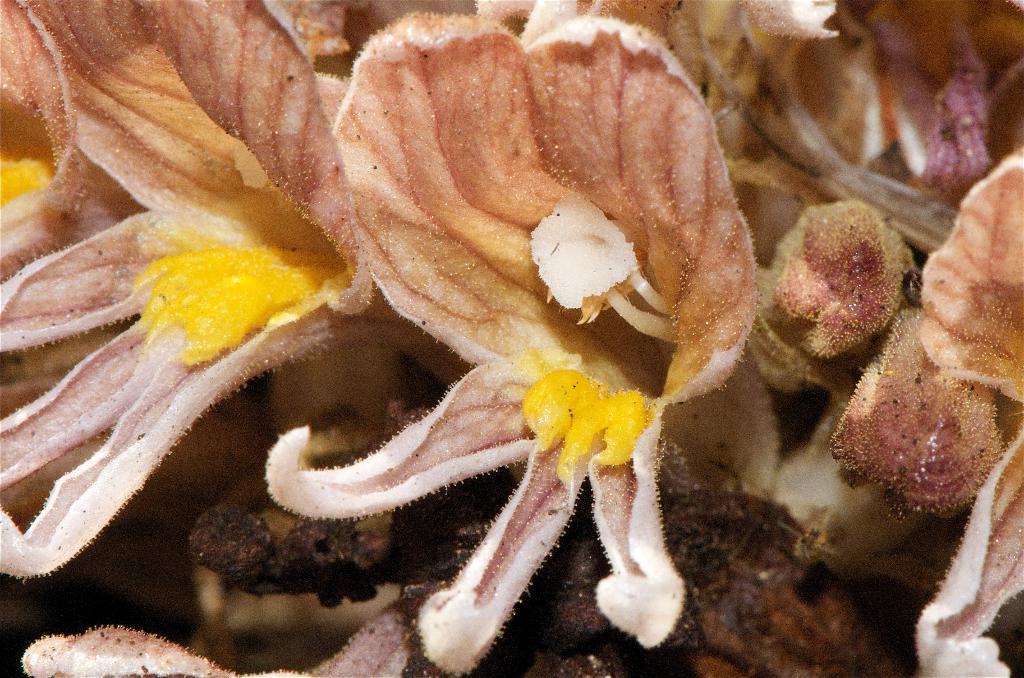Can you describe this image briefly? In this picture we can see some flowers, we can see petals and pollen grains of this flower. 